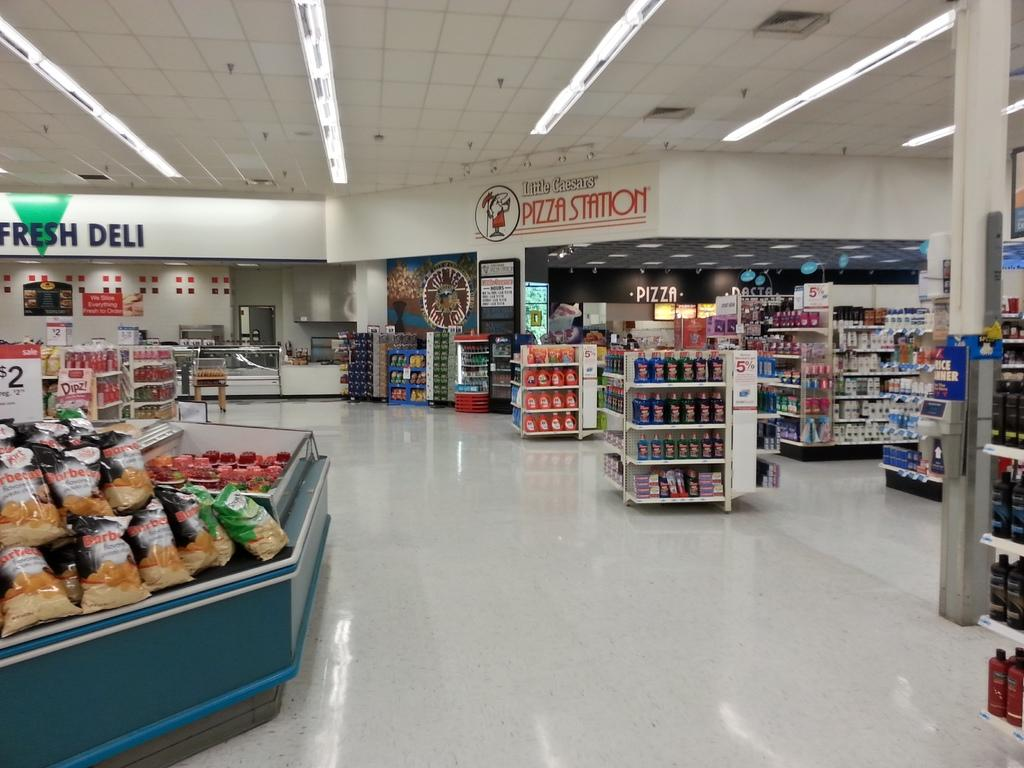<image>
Write a terse but informative summary of the picture. Area in a grocery store that says Pizza Station in the back. 